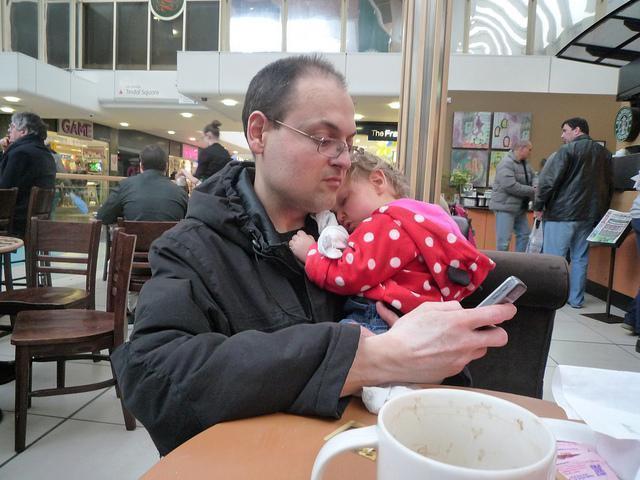Where is this man and child sitting?
Choose the right answer and clarify with the format: 'Answer: answer
Rationale: rationale.'
Options: Starbucks, peets, bus stop, orange julius. Answer: starbucks.
Rationale: The logo is visible in the background. 